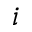Convert formula to latex. <formula><loc_0><loc_0><loc_500><loc_500>i</formula> 